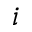Convert formula to latex. <formula><loc_0><loc_0><loc_500><loc_500>i</formula> 